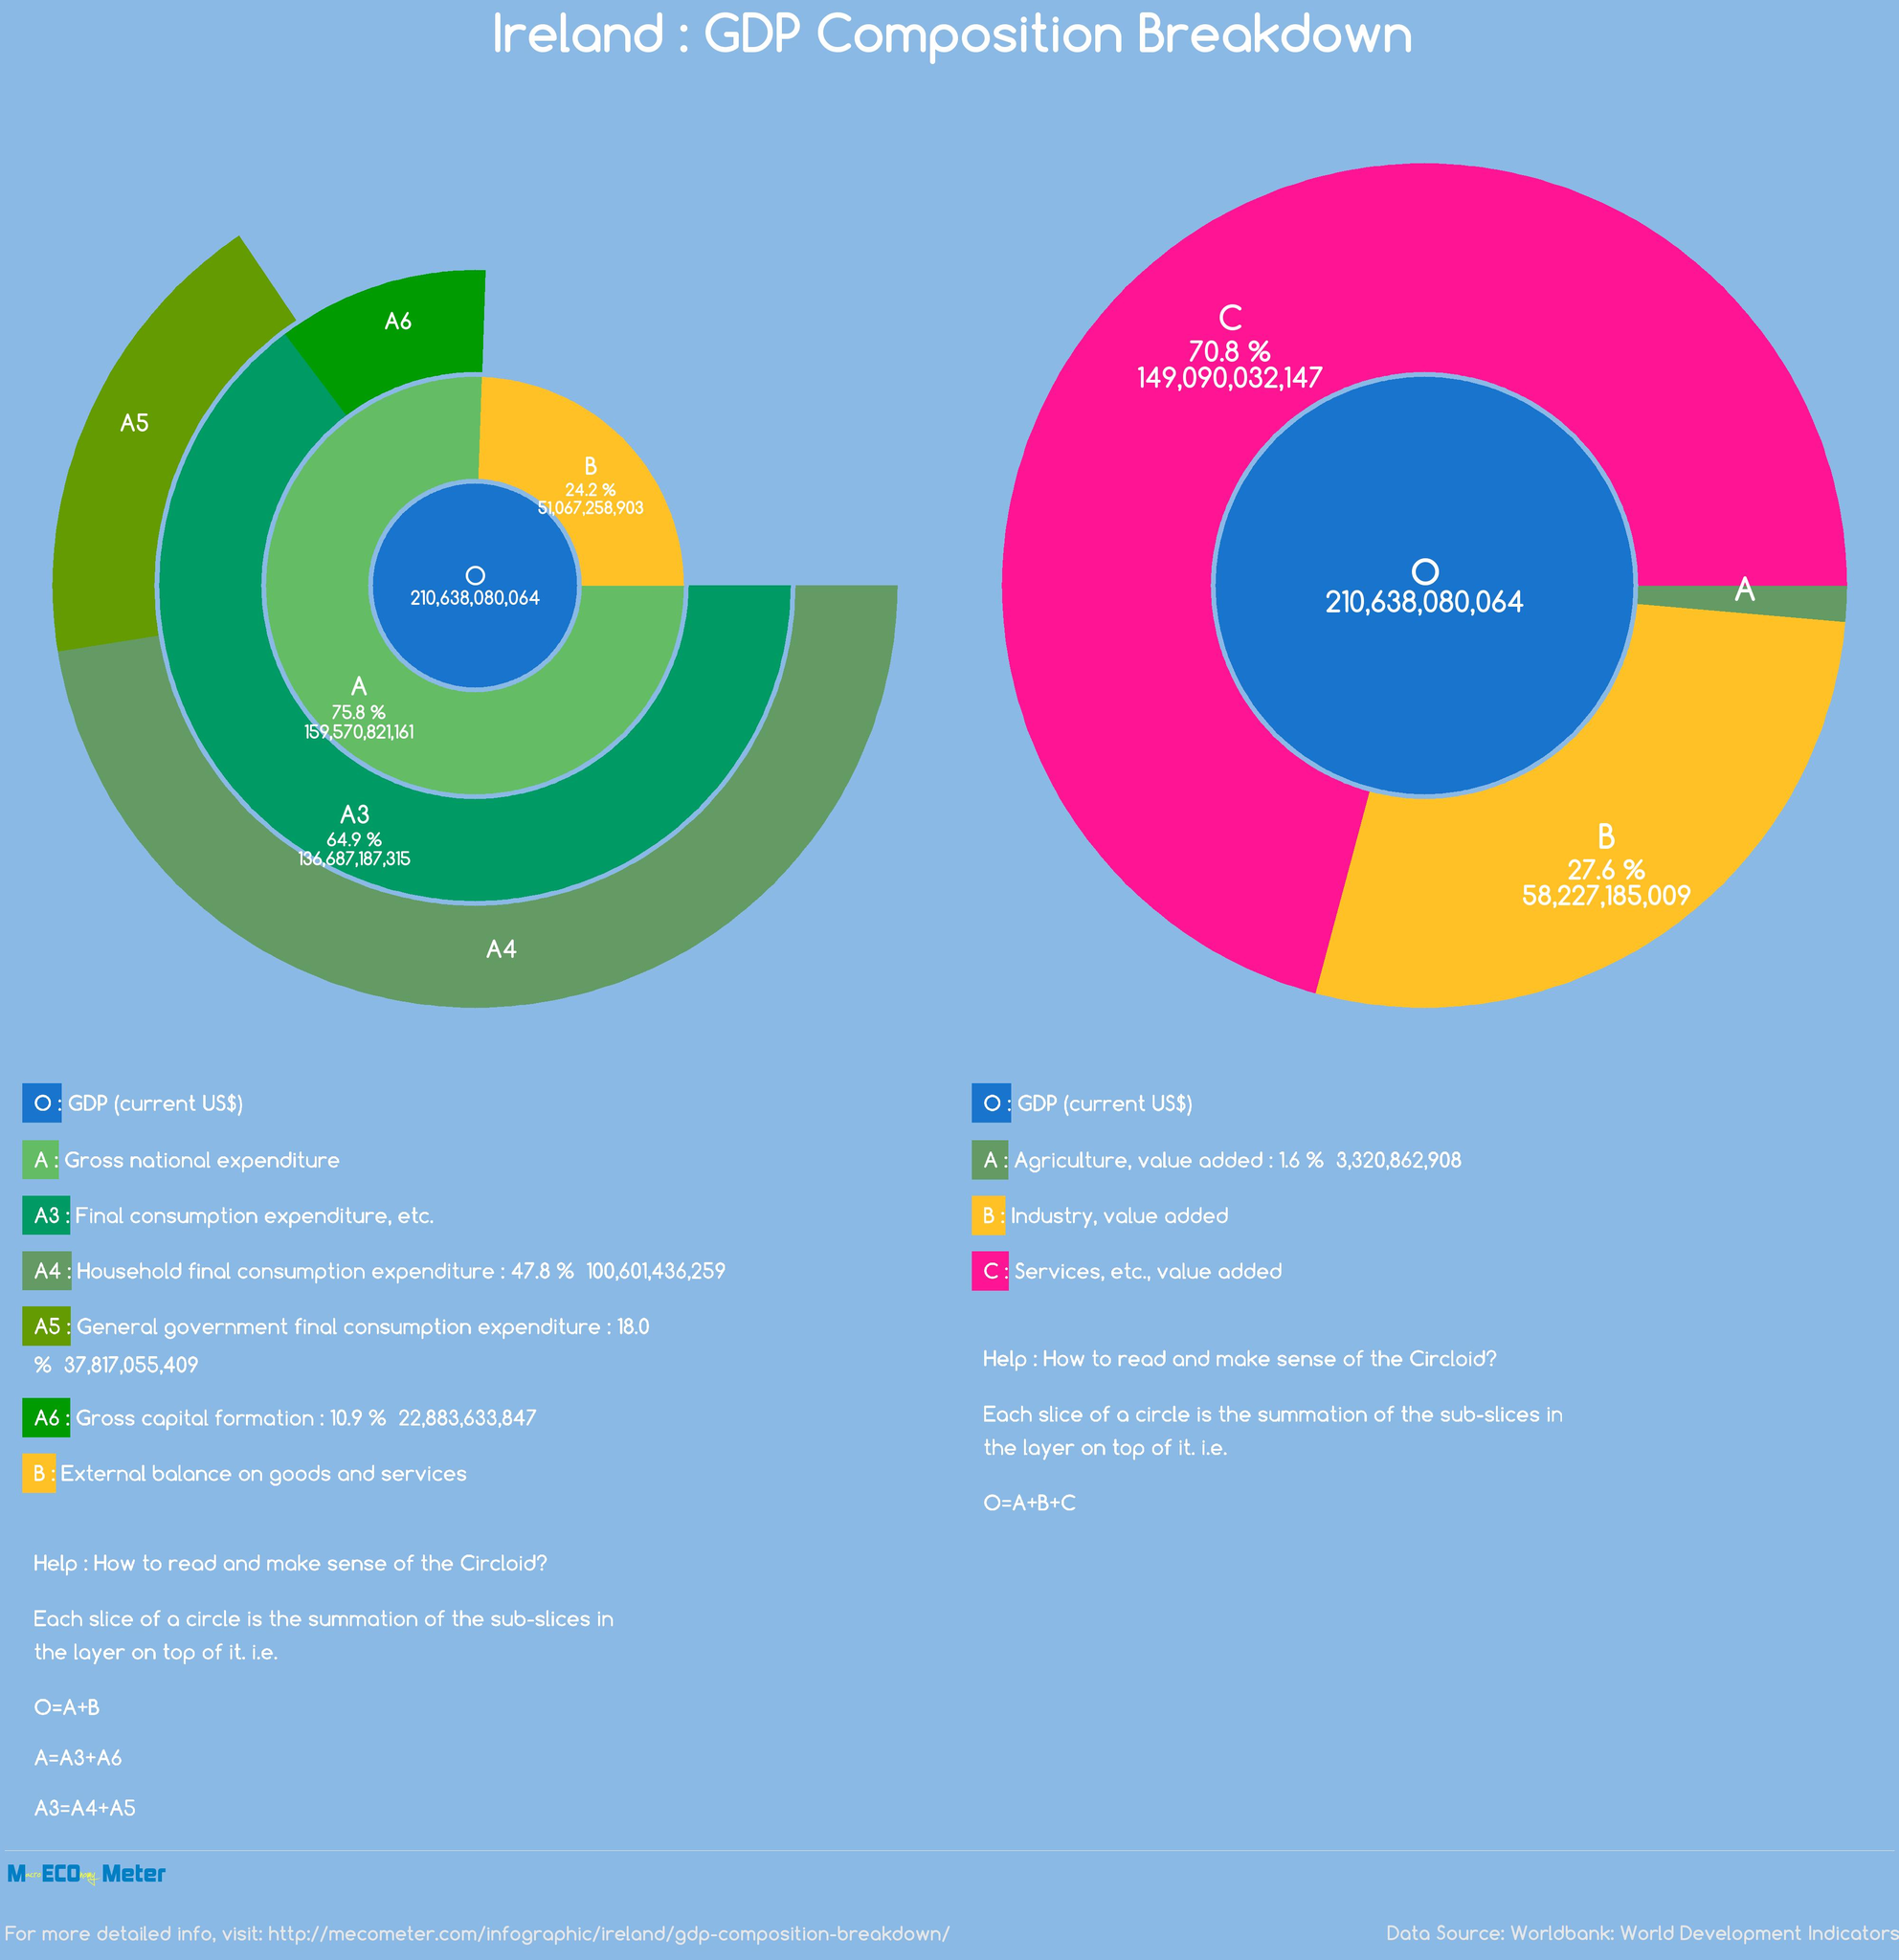List a handful of essential elements in this visual. Out of A3, A1, and A2, A1 has the highest share. Out of B and C, it is C that has the highest share. The industry is typically represented by the color orange. The service is color-coded as orange, pink, and green, with a predominance of pink. 